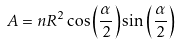Convert formula to latex. <formula><loc_0><loc_0><loc_500><loc_500>A = n R ^ { 2 } \cos \left ( \frac { \alpha } { 2 } \right ) \sin \left ( \frac { \alpha } { 2 } \right )</formula> 